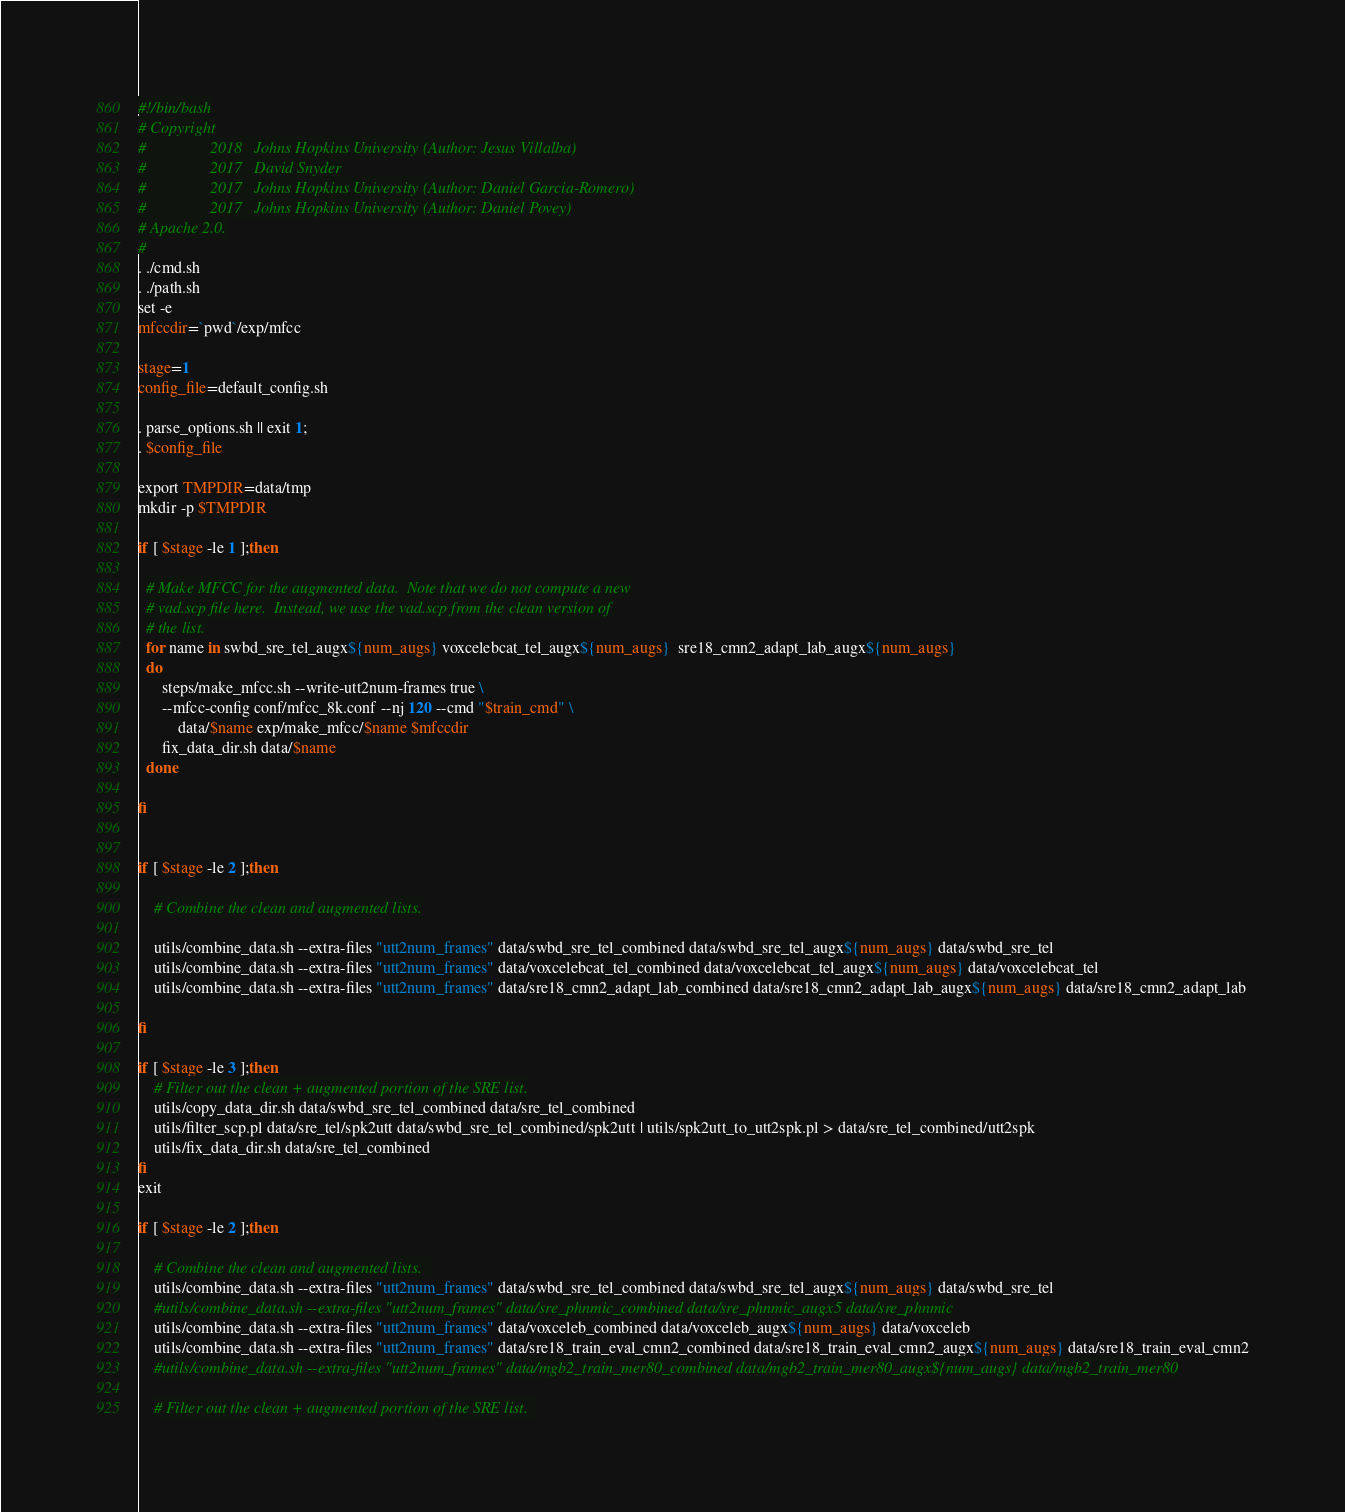Convert code to text. <code><loc_0><loc_0><loc_500><loc_500><_Bash_>#!/bin/bash
# Copyright
#                2018   Johns Hopkins University (Author: Jesus Villalba)
#                2017   David Snyder
#                2017   Johns Hopkins University (Author: Daniel Garcia-Romero)
#                2017   Johns Hopkins University (Author: Daniel Povey)
# Apache 2.0.
#
. ./cmd.sh
. ./path.sh
set -e
mfccdir=`pwd`/exp/mfcc

stage=1
config_file=default_config.sh

. parse_options.sh || exit 1;
. $config_file

export TMPDIR=data/tmp
mkdir -p $TMPDIR

if [ $stage -le 1 ];then
    
  # Make MFCC for the augmented data.  Note that we do not compute a new
  # vad.scp file here.  Instead, we use the vad.scp from the clean version of
  # the list.
  for name in swbd_sre_tel_augx${num_augs} voxcelebcat_tel_augx${num_augs}  sre18_cmn2_adapt_lab_augx${num_augs}
  do
      steps/make_mfcc.sh --write-utt2num-frames true \
	  --mfcc-config conf/mfcc_8k.conf --nj 120 --cmd "$train_cmd" \
      	  data/$name exp/make_mfcc/$name $mfccdir
      fix_data_dir.sh data/$name
  done

fi


if [ $stage -le 2 ];then

    # Combine the clean and augmented lists.

    utils/combine_data.sh --extra-files "utt2num_frames" data/swbd_sre_tel_combined data/swbd_sre_tel_augx${num_augs} data/swbd_sre_tel
    utils/combine_data.sh --extra-files "utt2num_frames" data/voxcelebcat_tel_combined data/voxcelebcat_tel_augx${num_augs} data/voxcelebcat_tel
    utils/combine_data.sh --extra-files "utt2num_frames" data/sre18_cmn2_adapt_lab_combined data/sre18_cmn2_adapt_lab_augx${num_augs} data/sre18_cmn2_adapt_lab

fi

if [ $stage -le 3 ];then
    # Filter out the clean + augmented portion of the SRE list.
    utils/copy_data_dir.sh data/swbd_sre_tel_combined data/sre_tel_combined
    utils/filter_scp.pl data/sre_tel/spk2utt data/swbd_sre_tel_combined/spk2utt | utils/spk2utt_to_utt2spk.pl > data/sre_tel_combined/utt2spk
    utils/fix_data_dir.sh data/sre_tel_combined
fi
exit

if [ $stage -le 2 ];then
    
    # Combine the clean and augmented lists.  
    utils/combine_data.sh --extra-files "utt2num_frames" data/swbd_sre_tel_combined data/swbd_sre_tel_augx${num_augs} data/swbd_sre_tel
    #utils/combine_data.sh --extra-files "utt2num_frames" data/sre_phnmic_combined data/sre_phnmic_augx5 data/sre_phnmic
    utils/combine_data.sh --extra-files "utt2num_frames" data/voxceleb_combined data/voxceleb_augx${num_augs} data/voxceleb
    utils/combine_data.sh --extra-files "utt2num_frames" data/sre18_train_eval_cmn2_combined data/sre18_train_eval_cmn2_augx${num_augs} data/sre18_train_eval_cmn2
    #utils/combine_data.sh --extra-files "utt2num_frames" data/mgb2_train_mer80_combined data/mgb2_train_mer80_augx${num_augs} data/mgb2_train_mer80

    # Filter out the clean + augmented portion of the SRE list.  </code> 